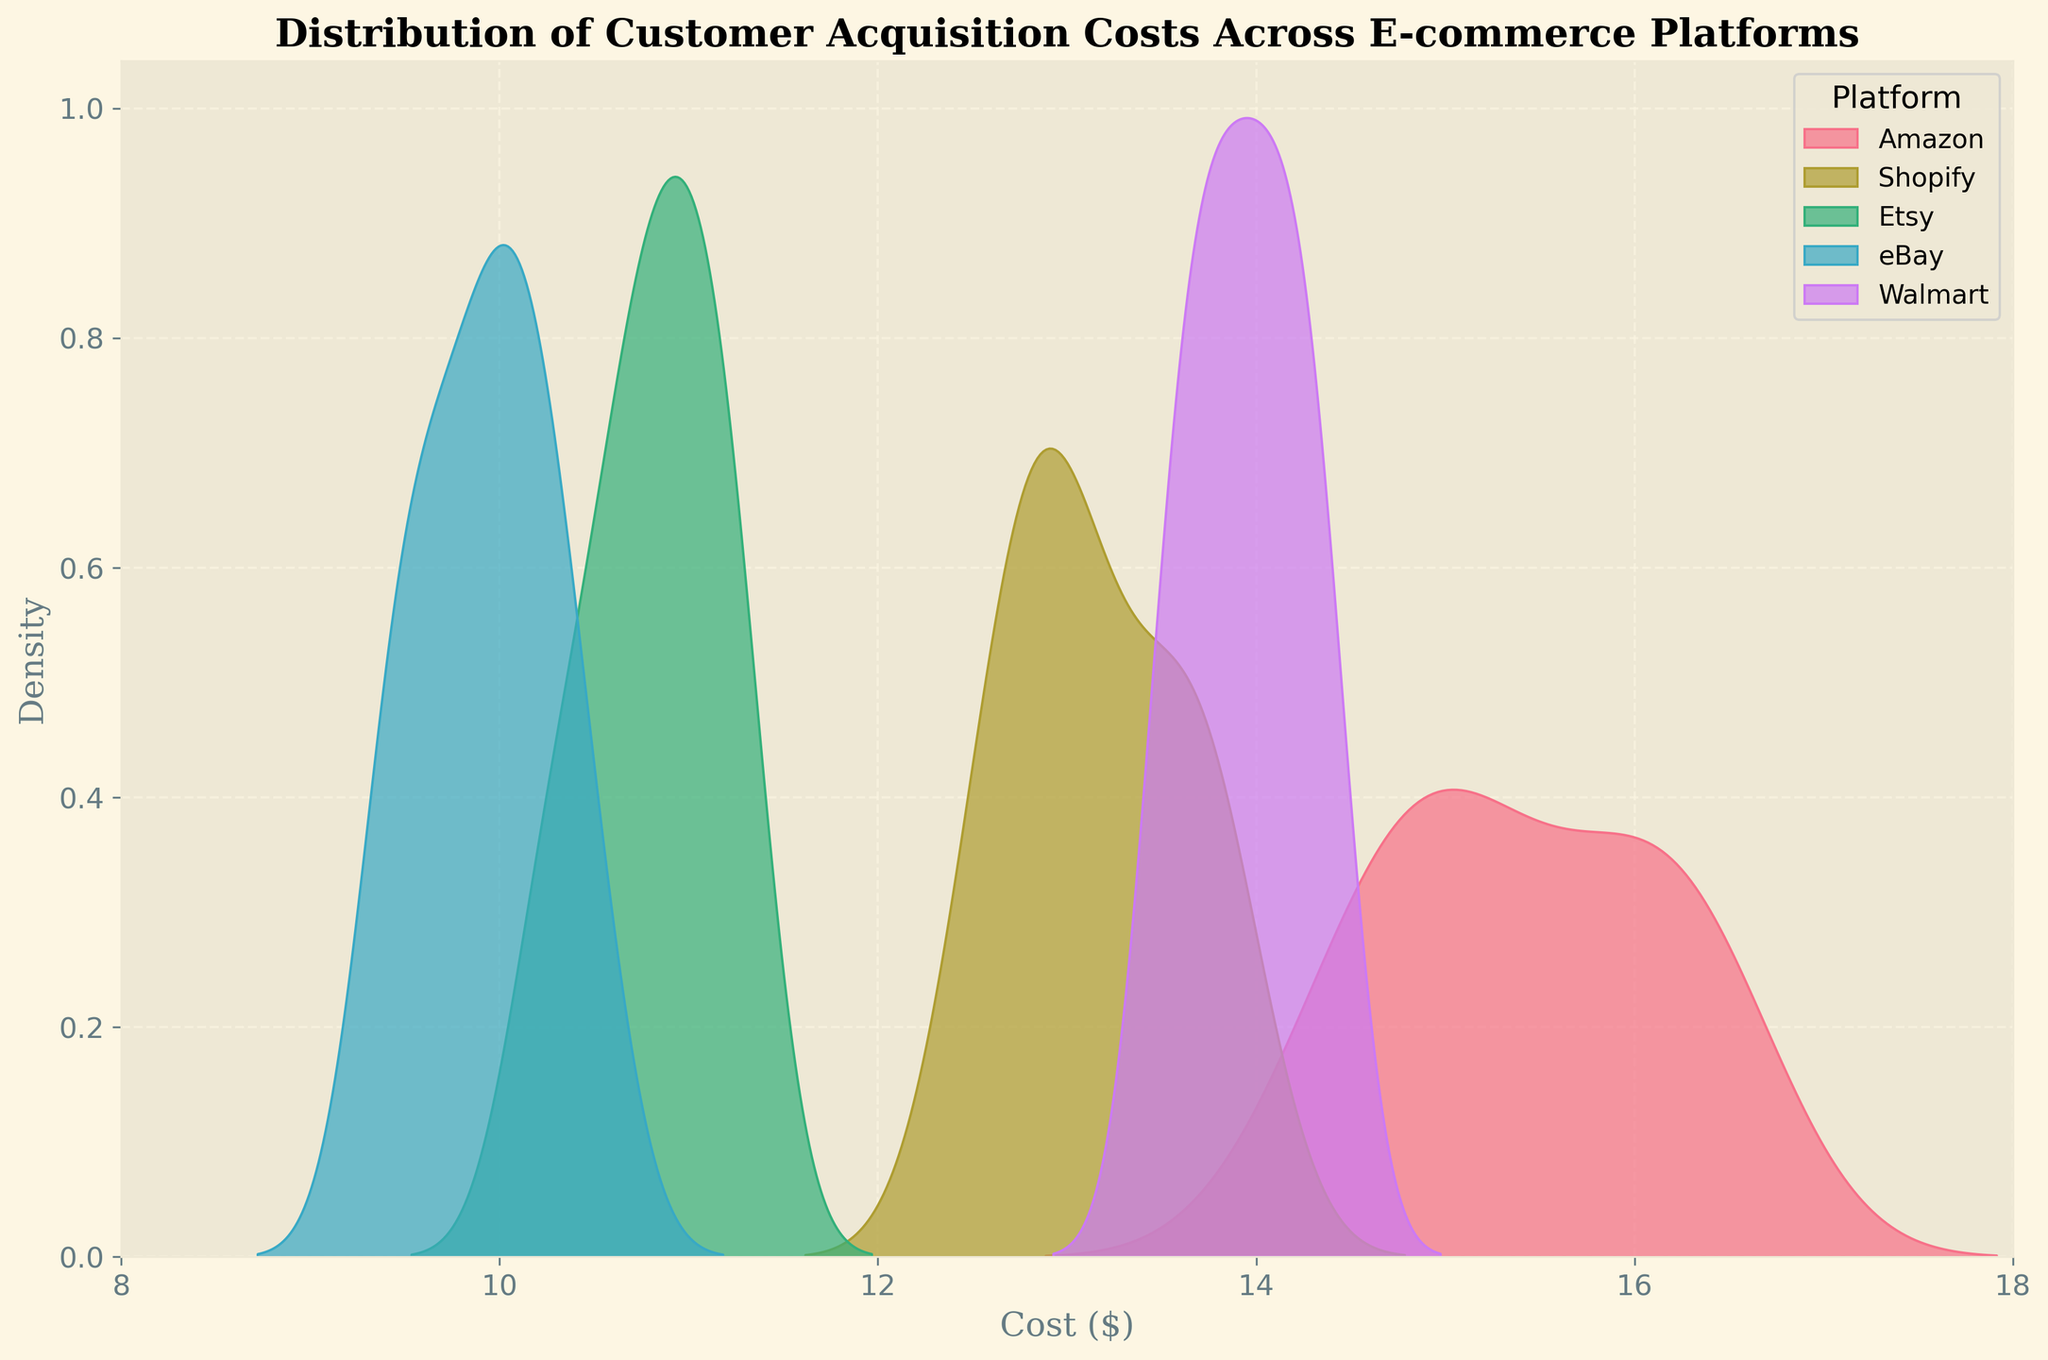what is the range of customer acquisition costs shown on the x-axis? The x-axis spans values from 8 to 18, indicating that the customer acquisition costs range from $8 to $18.
Answer: $8 to $18 which e-commerce platform has the highest peak in the density plot? By looking at the density plots, the platform with the highest peak in the distribution is Amazon.
Answer: Amazon how does the customer acquisition cost distribution of eBay compare to Etsy? The eBay distribution is slightly lower than Etsy's, as its peaks are to the left of Etsy's peaks.
Answer: eBay's costs are slightly lower which platform has the narrowest spread of customer acquisition costs? Considering the density plots, Etsy shows the narrowest spread, indicated by the narrower distribution.
Answer: Etsy which two platforms have overlapping ranges in their cost distributions? Shopify and Walmart have overlapping ranges in their cost distributions, noticeable from the mixture of their density plots.
Answer: Shopify and Walmart 